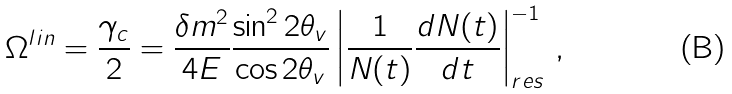<formula> <loc_0><loc_0><loc_500><loc_500>\Omega ^ { l i n } = \frac { \gamma _ { c } } { 2 } = \frac { \delta m ^ { 2 } } { 4 E } \frac { \sin ^ { 2 } { 2 \theta _ { v } } } { \cos { 2 \theta _ { v } } } \left | \frac { 1 } { N ( t ) } \frac { d N ( t ) } { d t } \right | ^ { - 1 } _ { r e s } \, ,</formula> 